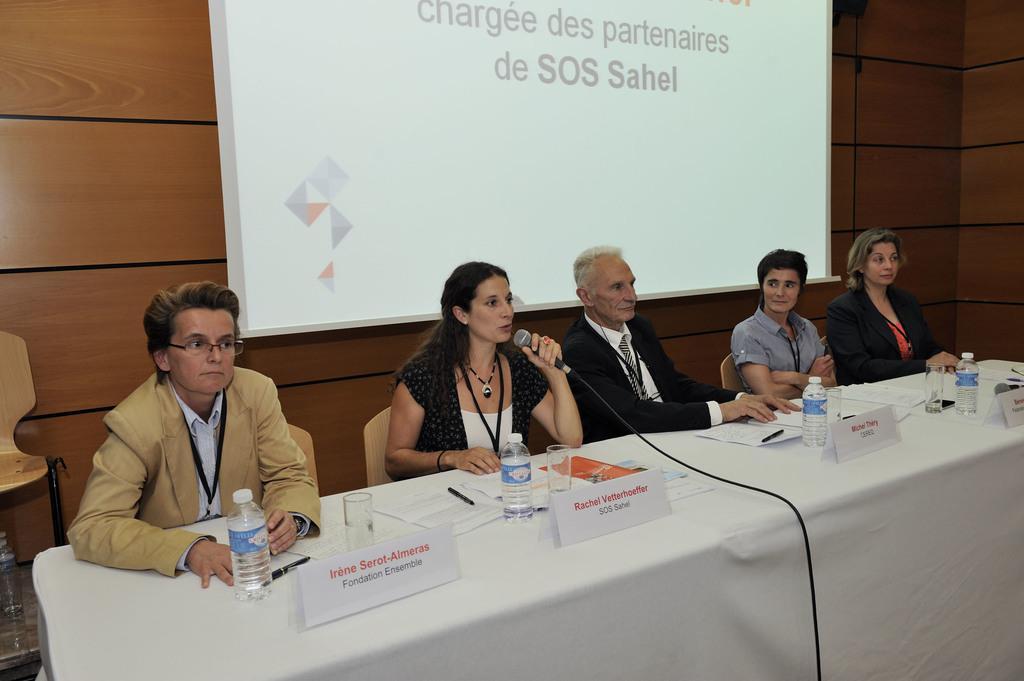How would you summarize this image in a sentence or two? In this image we can see people sitting, before them there is a table and we can see bottles, glasses, papers, pins and boards placed on the table. The lady sitting in the center is holding a mic in her hand. In the background there is a chair and a screen placed on the wall. 